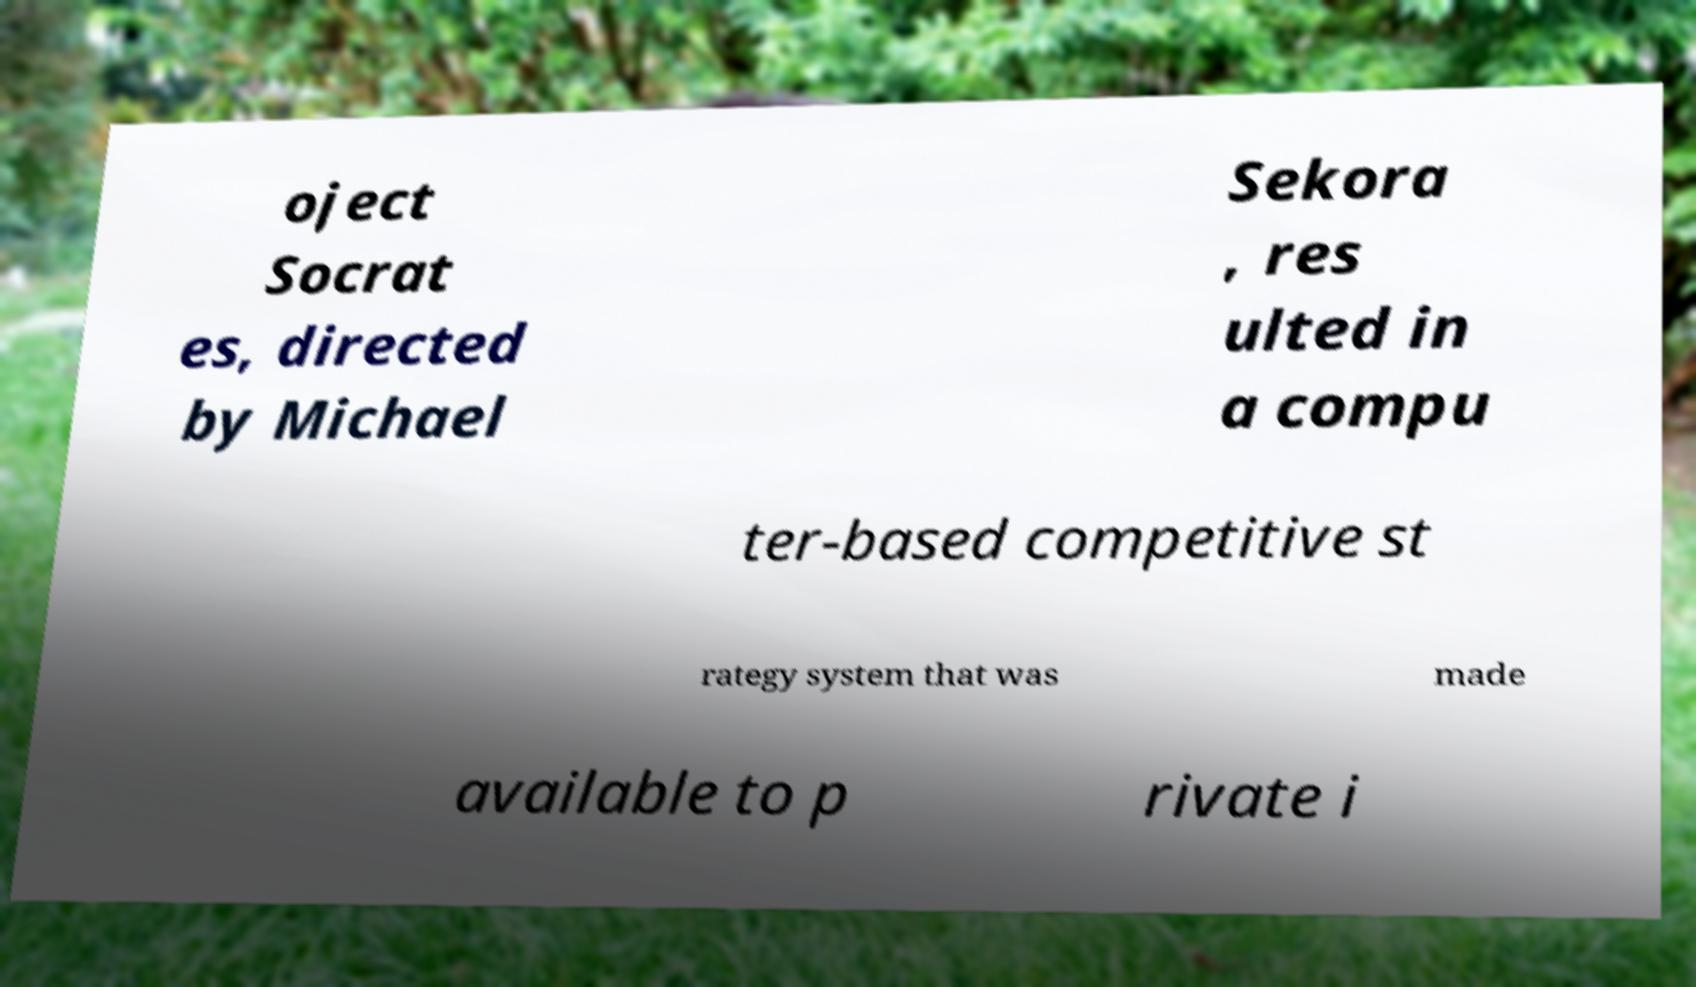There's text embedded in this image that I need extracted. Can you transcribe it verbatim? oject Socrat es, directed by Michael Sekora , res ulted in a compu ter-based competitive st rategy system that was made available to p rivate i 